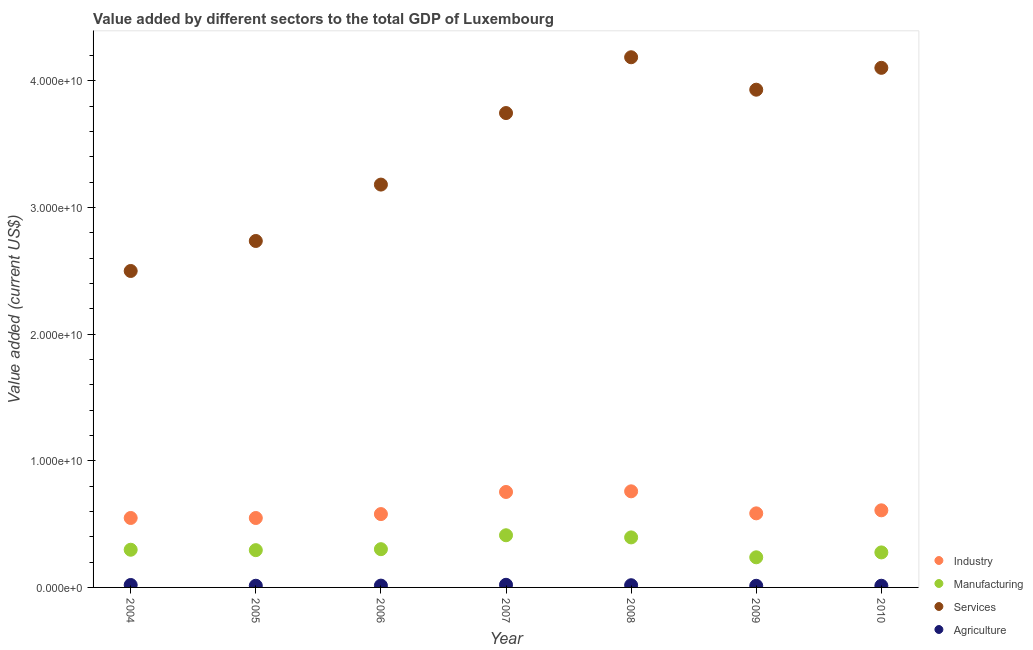How many different coloured dotlines are there?
Provide a succinct answer. 4. What is the value added by agricultural sector in 2005?
Provide a succinct answer. 1.33e+08. Across all years, what is the maximum value added by manufacturing sector?
Provide a short and direct response. 4.12e+09. Across all years, what is the minimum value added by services sector?
Your answer should be very brief. 2.50e+1. In which year was the value added by services sector minimum?
Your answer should be very brief. 2004. What is the total value added by industrial sector in the graph?
Keep it short and to the point. 4.38e+1. What is the difference between the value added by services sector in 2005 and that in 2008?
Offer a very short reply. -1.45e+1. What is the difference between the value added by agricultural sector in 2004 and the value added by services sector in 2005?
Provide a short and direct response. -2.72e+1. What is the average value added by industrial sector per year?
Offer a terse response. 6.26e+09. In the year 2006, what is the difference between the value added by agricultural sector and value added by services sector?
Your answer should be compact. -3.17e+1. In how many years, is the value added by agricultural sector greater than 2000000000 US$?
Your response must be concise. 0. What is the ratio of the value added by services sector in 2006 to that in 2010?
Ensure brevity in your answer.  0.78. Is the difference between the value added by services sector in 2005 and 2006 greater than the difference between the value added by industrial sector in 2005 and 2006?
Offer a very short reply. No. What is the difference between the highest and the second highest value added by agricultural sector?
Your answer should be compact. 1.63e+07. What is the difference between the highest and the lowest value added by manufacturing sector?
Keep it short and to the point. 1.74e+09. Is it the case that in every year, the sum of the value added by agricultural sector and value added by industrial sector is greater than the sum of value added by services sector and value added by manufacturing sector?
Your answer should be compact. No. Is it the case that in every year, the sum of the value added by industrial sector and value added by manufacturing sector is greater than the value added by services sector?
Offer a very short reply. No. Does the value added by agricultural sector monotonically increase over the years?
Keep it short and to the point. No. Is the value added by industrial sector strictly greater than the value added by manufacturing sector over the years?
Keep it short and to the point. Yes. Is the value added by manufacturing sector strictly less than the value added by industrial sector over the years?
Offer a very short reply. Yes. Are the values on the major ticks of Y-axis written in scientific E-notation?
Provide a short and direct response. Yes. Does the graph contain any zero values?
Offer a terse response. No. How are the legend labels stacked?
Keep it short and to the point. Vertical. What is the title of the graph?
Offer a terse response. Value added by different sectors to the total GDP of Luxembourg. What is the label or title of the X-axis?
Offer a terse response. Year. What is the label or title of the Y-axis?
Your answer should be compact. Value added (current US$). What is the Value added (current US$) in Industry in 2004?
Provide a short and direct response. 5.49e+09. What is the Value added (current US$) of Manufacturing in 2004?
Provide a succinct answer. 2.98e+09. What is the Value added (current US$) in Services in 2004?
Your answer should be very brief. 2.50e+1. What is the Value added (current US$) of Agriculture in 2004?
Your answer should be compact. 1.92e+08. What is the Value added (current US$) in Industry in 2005?
Give a very brief answer. 5.48e+09. What is the Value added (current US$) in Manufacturing in 2005?
Provide a short and direct response. 2.94e+09. What is the Value added (current US$) in Services in 2005?
Provide a succinct answer. 2.74e+1. What is the Value added (current US$) of Agriculture in 2005?
Your answer should be compact. 1.33e+08. What is the Value added (current US$) in Industry in 2006?
Give a very brief answer. 5.79e+09. What is the Value added (current US$) of Manufacturing in 2006?
Ensure brevity in your answer.  3.02e+09. What is the Value added (current US$) of Services in 2006?
Make the answer very short. 3.18e+1. What is the Value added (current US$) in Agriculture in 2006?
Your answer should be compact. 1.43e+08. What is the Value added (current US$) of Industry in 2007?
Your response must be concise. 7.54e+09. What is the Value added (current US$) of Manufacturing in 2007?
Offer a terse response. 4.12e+09. What is the Value added (current US$) of Services in 2007?
Your answer should be very brief. 3.75e+1. What is the Value added (current US$) in Agriculture in 2007?
Give a very brief answer. 2.08e+08. What is the Value added (current US$) in Industry in 2008?
Your answer should be compact. 7.59e+09. What is the Value added (current US$) in Manufacturing in 2008?
Your response must be concise. 3.95e+09. What is the Value added (current US$) in Services in 2008?
Your answer should be very brief. 4.19e+1. What is the Value added (current US$) of Agriculture in 2008?
Your response must be concise. 1.74e+08. What is the Value added (current US$) in Industry in 2009?
Make the answer very short. 5.85e+09. What is the Value added (current US$) of Manufacturing in 2009?
Ensure brevity in your answer.  2.38e+09. What is the Value added (current US$) in Services in 2009?
Make the answer very short. 3.93e+1. What is the Value added (current US$) in Agriculture in 2009?
Ensure brevity in your answer.  1.29e+08. What is the Value added (current US$) of Industry in 2010?
Offer a terse response. 6.09e+09. What is the Value added (current US$) in Manufacturing in 2010?
Keep it short and to the point. 2.77e+09. What is the Value added (current US$) in Services in 2010?
Give a very brief answer. 4.10e+1. What is the Value added (current US$) in Agriculture in 2010?
Give a very brief answer. 1.32e+08. Across all years, what is the maximum Value added (current US$) in Industry?
Ensure brevity in your answer.  7.59e+09. Across all years, what is the maximum Value added (current US$) of Manufacturing?
Your answer should be compact. 4.12e+09. Across all years, what is the maximum Value added (current US$) in Services?
Make the answer very short. 4.19e+1. Across all years, what is the maximum Value added (current US$) in Agriculture?
Offer a very short reply. 2.08e+08. Across all years, what is the minimum Value added (current US$) in Industry?
Give a very brief answer. 5.48e+09. Across all years, what is the minimum Value added (current US$) in Manufacturing?
Give a very brief answer. 2.38e+09. Across all years, what is the minimum Value added (current US$) in Services?
Your response must be concise. 2.50e+1. Across all years, what is the minimum Value added (current US$) in Agriculture?
Provide a succinct answer. 1.29e+08. What is the total Value added (current US$) of Industry in the graph?
Your answer should be very brief. 4.38e+1. What is the total Value added (current US$) of Manufacturing in the graph?
Your answer should be very brief. 2.22e+1. What is the total Value added (current US$) in Services in the graph?
Provide a succinct answer. 2.44e+11. What is the total Value added (current US$) in Agriculture in the graph?
Your answer should be compact. 1.11e+09. What is the difference between the Value added (current US$) of Industry in 2004 and that in 2005?
Your answer should be very brief. 2.57e+06. What is the difference between the Value added (current US$) of Manufacturing in 2004 and that in 2005?
Offer a terse response. 3.27e+07. What is the difference between the Value added (current US$) in Services in 2004 and that in 2005?
Offer a terse response. -2.37e+09. What is the difference between the Value added (current US$) of Agriculture in 2004 and that in 2005?
Offer a very short reply. 5.94e+07. What is the difference between the Value added (current US$) in Industry in 2004 and that in 2006?
Provide a succinct answer. -3.08e+08. What is the difference between the Value added (current US$) in Manufacturing in 2004 and that in 2006?
Your answer should be very brief. -4.37e+07. What is the difference between the Value added (current US$) in Services in 2004 and that in 2006?
Your answer should be compact. -6.82e+09. What is the difference between the Value added (current US$) of Agriculture in 2004 and that in 2006?
Offer a terse response. 4.88e+07. What is the difference between the Value added (current US$) in Industry in 2004 and that in 2007?
Your response must be concise. -2.05e+09. What is the difference between the Value added (current US$) in Manufacturing in 2004 and that in 2007?
Offer a very short reply. -1.14e+09. What is the difference between the Value added (current US$) of Services in 2004 and that in 2007?
Ensure brevity in your answer.  -1.25e+1. What is the difference between the Value added (current US$) of Agriculture in 2004 and that in 2007?
Keep it short and to the point. -1.63e+07. What is the difference between the Value added (current US$) of Industry in 2004 and that in 2008?
Offer a very short reply. -2.11e+09. What is the difference between the Value added (current US$) of Manufacturing in 2004 and that in 2008?
Your response must be concise. -9.74e+08. What is the difference between the Value added (current US$) of Services in 2004 and that in 2008?
Provide a short and direct response. -1.69e+1. What is the difference between the Value added (current US$) in Agriculture in 2004 and that in 2008?
Ensure brevity in your answer.  1.80e+07. What is the difference between the Value added (current US$) of Industry in 2004 and that in 2009?
Provide a short and direct response. -3.65e+08. What is the difference between the Value added (current US$) in Manufacturing in 2004 and that in 2009?
Offer a very short reply. 5.97e+08. What is the difference between the Value added (current US$) in Services in 2004 and that in 2009?
Your answer should be very brief. -1.43e+1. What is the difference between the Value added (current US$) in Agriculture in 2004 and that in 2009?
Make the answer very short. 6.30e+07. What is the difference between the Value added (current US$) in Industry in 2004 and that in 2010?
Your answer should be very brief. -6.05e+08. What is the difference between the Value added (current US$) of Manufacturing in 2004 and that in 2010?
Give a very brief answer. 2.12e+08. What is the difference between the Value added (current US$) of Services in 2004 and that in 2010?
Provide a short and direct response. -1.60e+1. What is the difference between the Value added (current US$) of Agriculture in 2004 and that in 2010?
Give a very brief answer. 5.98e+07. What is the difference between the Value added (current US$) of Industry in 2005 and that in 2006?
Offer a very short reply. -3.10e+08. What is the difference between the Value added (current US$) in Manufacturing in 2005 and that in 2006?
Offer a terse response. -7.64e+07. What is the difference between the Value added (current US$) of Services in 2005 and that in 2006?
Provide a succinct answer. -4.45e+09. What is the difference between the Value added (current US$) in Agriculture in 2005 and that in 2006?
Offer a very short reply. -1.06e+07. What is the difference between the Value added (current US$) of Industry in 2005 and that in 2007?
Your answer should be very brief. -2.06e+09. What is the difference between the Value added (current US$) in Manufacturing in 2005 and that in 2007?
Offer a terse response. -1.18e+09. What is the difference between the Value added (current US$) of Services in 2005 and that in 2007?
Make the answer very short. -1.01e+1. What is the difference between the Value added (current US$) in Agriculture in 2005 and that in 2007?
Make the answer very short. -7.56e+07. What is the difference between the Value added (current US$) in Industry in 2005 and that in 2008?
Your answer should be very brief. -2.11e+09. What is the difference between the Value added (current US$) of Manufacturing in 2005 and that in 2008?
Provide a short and direct response. -1.01e+09. What is the difference between the Value added (current US$) in Services in 2005 and that in 2008?
Make the answer very short. -1.45e+1. What is the difference between the Value added (current US$) of Agriculture in 2005 and that in 2008?
Your response must be concise. -4.13e+07. What is the difference between the Value added (current US$) of Industry in 2005 and that in 2009?
Give a very brief answer. -3.68e+08. What is the difference between the Value added (current US$) in Manufacturing in 2005 and that in 2009?
Give a very brief answer. 5.65e+08. What is the difference between the Value added (current US$) in Services in 2005 and that in 2009?
Offer a very short reply. -1.19e+1. What is the difference between the Value added (current US$) of Agriculture in 2005 and that in 2009?
Provide a short and direct response. 3.62e+06. What is the difference between the Value added (current US$) of Industry in 2005 and that in 2010?
Offer a terse response. -6.07e+08. What is the difference between the Value added (current US$) of Manufacturing in 2005 and that in 2010?
Your response must be concise. 1.79e+08. What is the difference between the Value added (current US$) of Services in 2005 and that in 2010?
Make the answer very short. -1.37e+1. What is the difference between the Value added (current US$) in Agriculture in 2005 and that in 2010?
Your response must be concise. 3.69e+05. What is the difference between the Value added (current US$) in Industry in 2006 and that in 2007?
Your response must be concise. -1.75e+09. What is the difference between the Value added (current US$) in Manufacturing in 2006 and that in 2007?
Ensure brevity in your answer.  -1.10e+09. What is the difference between the Value added (current US$) of Services in 2006 and that in 2007?
Make the answer very short. -5.65e+09. What is the difference between the Value added (current US$) of Agriculture in 2006 and that in 2007?
Offer a very short reply. -6.51e+07. What is the difference between the Value added (current US$) in Industry in 2006 and that in 2008?
Give a very brief answer. -1.80e+09. What is the difference between the Value added (current US$) in Manufacturing in 2006 and that in 2008?
Provide a succinct answer. -9.30e+08. What is the difference between the Value added (current US$) of Services in 2006 and that in 2008?
Give a very brief answer. -1.01e+1. What is the difference between the Value added (current US$) in Agriculture in 2006 and that in 2008?
Your response must be concise. -3.08e+07. What is the difference between the Value added (current US$) in Industry in 2006 and that in 2009?
Keep it short and to the point. -5.74e+07. What is the difference between the Value added (current US$) of Manufacturing in 2006 and that in 2009?
Provide a short and direct response. 6.41e+08. What is the difference between the Value added (current US$) of Services in 2006 and that in 2009?
Make the answer very short. -7.49e+09. What is the difference between the Value added (current US$) in Agriculture in 2006 and that in 2009?
Keep it short and to the point. 1.42e+07. What is the difference between the Value added (current US$) in Industry in 2006 and that in 2010?
Your answer should be compact. -2.97e+08. What is the difference between the Value added (current US$) in Manufacturing in 2006 and that in 2010?
Make the answer very short. 2.55e+08. What is the difference between the Value added (current US$) of Services in 2006 and that in 2010?
Your answer should be compact. -9.22e+09. What is the difference between the Value added (current US$) in Agriculture in 2006 and that in 2010?
Give a very brief answer. 1.09e+07. What is the difference between the Value added (current US$) in Industry in 2007 and that in 2008?
Provide a succinct answer. -5.10e+07. What is the difference between the Value added (current US$) of Manufacturing in 2007 and that in 2008?
Give a very brief answer. 1.70e+08. What is the difference between the Value added (current US$) of Services in 2007 and that in 2008?
Make the answer very short. -4.41e+09. What is the difference between the Value added (current US$) of Agriculture in 2007 and that in 2008?
Your answer should be compact. 3.43e+07. What is the difference between the Value added (current US$) of Industry in 2007 and that in 2009?
Offer a very short reply. 1.69e+09. What is the difference between the Value added (current US$) of Manufacturing in 2007 and that in 2009?
Give a very brief answer. 1.74e+09. What is the difference between the Value added (current US$) of Services in 2007 and that in 2009?
Make the answer very short. -1.84e+09. What is the difference between the Value added (current US$) in Agriculture in 2007 and that in 2009?
Provide a succinct answer. 7.93e+07. What is the difference between the Value added (current US$) of Industry in 2007 and that in 2010?
Your answer should be compact. 1.45e+09. What is the difference between the Value added (current US$) of Manufacturing in 2007 and that in 2010?
Your response must be concise. 1.36e+09. What is the difference between the Value added (current US$) of Services in 2007 and that in 2010?
Offer a very short reply. -3.57e+09. What is the difference between the Value added (current US$) in Agriculture in 2007 and that in 2010?
Provide a succinct answer. 7.60e+07. What is the difference between the Value added (current US$) of Industry in 2008 and that in 2009?
Ensure brevity in your answer.  1.74e+09. What is the difference between the Value added (current US$) in Manufacturing in 2008 and that in 2009?
Keep it short and to the point. 1.57e+09. What is the difference between the Value added (current US$) in Services in 2008 and that in 2009?
Ensure brevity in your answer.  2.56e+09. What is the difference between the Value added (current US$) in Agriculture in 2008 and that in 2009?
Provide a succinct answer. 4.50e+07. What is the difference between the Value added (current US$) of Industry in 2008 and that in 2010?
Your answer should be very brief. 1.50e+09. What is the difference between the Value added (current US$) in Manufacturing in 2008 and that in 2010?
Offer a very short reply. 1.19e+09. What is the difference between the Value added (current US$) in Services in 2008 and that in 2010?
Make the answer very short. 8.35e+08. What is the difference between the Value added (current US$) in Agriculture in 2008 and that in 2010?
Provide a succinct answer. 4.17e+07. What is the difference between the Value added (current US$) in Industry in 2009 and that in 2010?
Give a very brief answer. -2.40e+08. What is the difference between the Value added (current US$) of Manufacturing in 2009 and that in 2010?
Keep it short and to the point. -3.86e+08. What is the difference between the Value added (current US$) of Services in 2009 and that in 2010?
Provide a short and direct response. -1.73e+09. What is the difference between the Value added (current US$) in Agriculture in 2009 and that in 2010?
Provide a short and direct response. -3.25e+06. What is the difference between the Value added (current US$) in Industry in 2004 and the Value added (current US$) in Manufacturing in 2005?
Give a very brief answer. 2.54e+09. What is the difference between the Value added (current US$) of Industry in 2004 and the Value added (current US$) of Services in 2005?
Your answer should be compact. -2.19e+1. What is the difference between the Value added (current US$) in Industry in 2004 and the Value added (current US$) in Agriculture in 2005?
Make the answer very short. 5.35e+09. What is the difference between the Value added (current US$) of Manufacturing in 2004 and the Value added (current US$) of Services in 2005?
Keep it short and to the point. -2.44e+1. What is the difference between the Value added (current US$) in Manufacturing in 2004 and the Value added (current US$) in Agriculture in 2005?
Your response must be concise. 2.84e+09. What is the difference between the Value added (current US$) in Services in 2004 and the Value added (current US$) in Agriculture in 2005?
Your answer should be compact. 2.49e+1. What is the difference between the Value added (current US$) of Industry in 2004 and the Value added (current US$) of Manufacturing in 2006?
Make the answer very short. 2.46e+09. What is the difference between the Value added (current US$) of Industry in 2004 and the Value added (current US$) of Services in 2006?
Offer a very short reply. -2.63e+1. What is the difference between the Value added (current US$) of Industry in 2004 and the Value added (current US$) of Agriculture in 2006?
Ensure brevity in your answer.  5.34e+09. What is the difference between the Value added (current US$) of Manufacturing in 2004 and the Value added (current US$) of Services in 2006?
Provide a succinct answer. -2.88e+1. What is the difference between the Value added (current US$) of Manufacturing in 2004 and the Value added (current US$) of Agriculture in 2006?
Offer a terse response. 2.83e+09. What is the difference between the Value added (current US$) of Services in 2004 and the Value added (current US$) of Agriculture in 2006?
Provide a succinct answer. 2.49e+1. What is the difference between the Value added (current US$) of Industry in 2004 and the Value added (current US$) of Manufacturing in 2007?
Give a very brief answer. 1.36e+09. What is the difference between the Value added (current US$) in Industry in 2004 and the Value added (current US$) in Services in 2007?
Give a very brief answer. -3.20e+1. What is the difference between the Value added (current US$) in Industry in 2004 and the Value added (current US$) in Agriculture in 2007?
Provide a succinct answer. 5.28e+09. What is the difference between the Value added (current US$) in Manufacturing in 2004 and the Value added (current US$) in Services in 2007?
Your answer should be compact. -3.45e+1. What is the difference between the Value added (current US$) of Manufacturing in 2004 and the Value added (current US$) of Agriculture in 2007?
Your response must be concise. 2.77e+09. What is the difference between the Value added (current US$) in Services in 2004 and the Value added (current US$) in Agriculture in 2007?
Give a very brief answer. 2.48e+1. What is the difference between the Value added (current US$) of Industry in 2004 and the Value added (current US$) of Manufacturing in 2008?
Your response must be concise. 1.53e+09. What is the difference between the Value added (current US$) of Industry in 2004 and the Value added (current US$) of Services in 2008?
Provide a short and direct response. -3.64e+1. What is the difference between the Value added (current US$) in Industry in 2004 and the Value added (current US$) in Agriculture in 2008?
Give a very brief answer. 5.31e+09. What is the difference between the Value added (current US$) of Manufacturing in 2004 and the Value added (current US$) of Services in 2008?
Ensure brevity in your answer.  -3.89e+1. What is the difference between the Value added (current US$) of Manufacturing in 2004 and the Value added (current US$) of Agriculture in 2008?
Give a very brief answer. 2.80e+09. What is the difference between the Value added (current US$) of Services in 2004 and the Value added (current US$) of Agriculture in 2008?
Provide a succinct answer. 2.48e+1. What is the difference between the Value added (current US$) in Industry in 2004 and the Value added (current US$) in Manufacturing in 2009?
Keep it short and to the point. 3.11e+09. What is the difference between the Value added (current US$) of Industry in 2004 and the Value added (current US$) of Services in 2009?
Ensure brevity in your answer.  -3.38e+1. What is the difference between the Value added (current US$) of Industry in 2004 and the Value added (current US$) of Agriculture in 2009?
Your answer should be compact. 5.36e+09. What is the difference between the Value added (current US$) in Manufacturing in 2004 and the Value added (current US$) in Services in 2009?
Provide a succinct answer. -3.63e+1. What is the difference between the Value added (current US$) of Manufacturing in 2004 and the Value added (current US$) of Agriculture in 2009?
Offer a terse response. 2.85e+09. What is the difference between the Value added (current US$) of Services in 2004 and the Value added (current US$) of Agriculture in 2009?
Make the answer very short. 2.49e+1. What is the difference between the Value added (current US$) of Industry in 2004 and the Value added (current US$) of Manufacturing in 2010?
Your response must be concise. 2.72e+09. What is the difference between the Value added (current US$) of Industry in 2004 and the Value added (current US$) of Services in 2010?
Provide a succinct answer. -3.56e+1. What is the difference between the Value added (current US$) of Industry in 2004 and the Value added (current US$) of Agriculture in 2010?
Make the answer very short. 5.35e+09. What is the difference between the Value added (current US$) in Manufacturing in 2004 and the Value added (current US$) in Services in 2010?
Provide a succinct answer. -3.81e+1. What is the difference between the Value added (current US$) of Manufacturing in 2004 and the Value added (current US$) of Agriculture in 2010?
Your response must be concise. 2.84e+09. What is the difference between the Value added (current US$) of Services in 2004 and the Value added (current US$) of Agriculture in 2010?
Give a very brief answer. 2.49e+1. What is the difference between the Value added (current US$) of Industry in 2005 and the Value added (current US$) of Manufacturing in 2006?
Give a very brief answer. 2.46e+09. What is the difference between the Value added (current US$) in Industry in 2005 and the Value added (current US$) in Services in 2006?
Your answer should be compact. -2.63e+1. What is the difference between the Value added (current US$) in Industry in 2005 and the Value added (current US$) in Agriculture in 2006?
Your answer should be compact. 5.34e+09. What is the difference between the Value added (current US$) of Manufacturing in 2005 and the Value added (current US$) of Services in 2006?
Give a very brief answer. -2.89e+1. What is the difference between the Value added (current US$) of Manufacturing in 2005 and the Value added (current US$) of Agriculture in 2006?
Offer a very short reply. 2.80e+09. What is the difference between the Value added (current US$) in Services in 2005 and the Value added (current US$) in Agriculture in 2006?
Provide a short and direct response. 2.72e+1. What is the difference between the Value added (current US$) in Industry in 2005 and the Value added (current US$) in Manufacturing in 2007?
Ensure brevity in your answer.  1.36e+09. What is the difference between the Value added (current US$) of Industry in 2005 and the Value added (current US$) of Services in 2007?
Ensure brevity in your answer.  -3.20e+1. What is the difference between the Value added (current US$) in Industry in 2005 and the Value added (current US$) in Agriculture in 2007?
Give a very brief answer. 5.27e+09. What is the difference between the Value added (current US$) in Manufacturing in 2005 and the Value added (current US$) in Services in 2007?
Your answer should be very brief. -3.45e+1. What is the difference between the Value added (current US$) of Manufacturing in 2005 and the Value added (current US$) of Agriculture in 2007?
Offer a terse response. 2.74e+09. What is the difference between the Value added (current US$) of Services in 2005 and the Value added (current US$) of Agriculture in 2007?
Your answer should be very brief. 2.72e+1. What is the difference between the Value added (current US$) in Industry in 2005 and the Value added (current US$) in Manufacturing in 2008?
Your answer should be very brief. 1.53e+09. What is the difference between the Value added (current US$) in Industry in 2005 and the Value added (current US$) in Services in 2008?
Provide a succinct answer. -3.64e+1. What is the difference between the Value added (current US$) in Industry in 2005 and the Value added (current US$) in Agriculture in 2008?
Ensure brevity in your answer.  5.31e+09. What is the difference between the Value added (current US$) in Manufacturing in 2005 and the Value added (current US$) in Services in 2008?
Offer a very short reply. -3.89e+1. What is the difference between the Value added (current US$) of Manufacturing in 2005 and the Value added (current US$) of Agriculture in 2008?
Your answer should be compact. 2.77e+09. What is the difference between the Value added (current US$) in Services in 2005 and the Value added (current US$) in Agriculture in 2008?
Your response must be concise. 2.72e+1. What is the difference between the Value added (current US$) in Industry in 2005 and the Value added (current US$) in Manufacturing in 2009?
Ensure brevity in your answer.  3.10e+09. What is the difference between the Value added (current US$) of Industry in 2005 and the Value added (current US$) of Services in 2009?
Make the answer very short. -3.38e+1. What is the difference between the Value added (current US$) in Industry in 2005 and the Value added (current US$) in Agriculture in 2009?
Offer a very short reply. 5.35e+09. What is the difference between the Value added (current US$) in Manufacturing in 2005 and the Value added (current US$) in Services in 2009?
Keep it short and to the point. -3.64e+1. What is the difference between the Value added (current US$) in Manufacturing in 2005 and the Value added (current US$) in Agriculture in 2009?
Make the answer very short. 2.82e+09. What is the difference between the Value added (current US$) of Services in 2005 and the Value added (current US$) of Agriculture in 2009?
Your answer should be compact. 2.72e+1. What is the difference between the Value added (current US$) of Industry in 2005 and the Value added (current US$) of Manufacturing in 2010?
Your response must be concise. 2.72e+09. What is the difference between the Value added (current US$) of Industry in 2005 and the Value added (current US$) of Services in 2010?
Keep it short and to the point. -3.56e+1. What is the difference between the Value added (current US$) of Industry in 2005 and the Value added (current US$) of Agriculture in 2010?
Offer a very short reply. 5.35e+09. What is the difference between the Value added (current US$) in Manufacturing in 2005 and the Value added (current US$) in Services in 2010?
Your answer should be compact. -3.81e+1. What is the difference between the Value added (current US$) of Manufacturing in 2005 and the Value added (current US$) of Agriculture in 2010?
Ensure brevity in your answer.  2.81e+09. What is the difference between the Value added (current US$) in Services in 2005 and the Value added (current US$) in Agriculture in 2010?
Make the answer very short. 2.72e+1. What is the difference between the Value added (current US$) in Industry in 2006 and the Value added (current US$) in Manufacturing in 2007?
Offer a terse response. 1.67e+09. What is the difference between the Value added (current US$) in Industry in 2006 and the Value added (current US$) in Services in 2007?
Make the answer very short. -3.17e+1. What is the difference between the Value added (current US$) in Industry in 2006 and the Value added (current US$) in Agriculture in 2007?
Ensure brevity in your answer.  5.58e+09. What is the difference between the Value added (current US$) in Manufacturing in 2006 and the Value added (current US$) in Services in 2007?
Your answer should be very brief. -3.44e+1. What is the difference between the Value added (current US$) of Manufacturing in 2006 and the Value added (current US$) of Agriculture in 2007?
Your answer should be compact. 2.81e+09. What is the difference between the Value added (current US$) of Services in 2006 and the Value added (current US$) of Agriculture in 2007?
Your answer should be very brief. 3.16e+1. What is the difference between the Value added (current US$) in Industry in 2006 and the Value added (current US$) in Manufacturing in 2008?
Your answer should be compact. 1.84e+09. What is the difference between the Value added (current US$) of Industry in 2006 and the Value added (current US$) of Services in 2008?
Your response must be concise. -3.61e+1. What is the difference between the Value added (current US$) of Industry in 2006 and the Value added (current US$) of Agriculture in 2008?
Offer a terse response. 5.62e+09. What is the difference between the Value added (current US$) of Manufacturing in 2006 and the Value added (current US$) of Services in 2008?
Your answer should be very brief. -3.89e+1. What is the difference between the Value added (current US$) in Manufacturing in 2006 and the Value added (current US$) in Agriculture in 2008?
Ensure brevity in your answer.  2.85e+09. What is the difference between the Value added (current US$) of Services in 2006 and the Value added (current US$) of Agriculture in 2008?
Keep it short and to the point. 3.16e+1. What is the difference between the Value added (current US$) in Industry in 2006 and the Value added (current US$) in Manufacturing in 2009?
Offer a terse response. 3.41e+09. What is the difference between the Value added (current US$) of Industry in 2006 and the Value added (current US$) of Services in 2009?
Give a very brief answer. -3.35e+1. What is the difference between the Value added (current US$) in Industry in 2006 and the Value added (current US$) in Agriculture in 2009?
Your response must be concise. 5.66e+09. What is the difference between the Value added (current US$) of Manufacturing in 2006 and the Value added (current US$) of Services in 2009?
Provide a succinct answer. -3.63e+1. What is the difference between the Value added (current US$) in Manufacturing in 2006 and the Value added (current US$) in Agriculture in 2009?
Make the answer very short. 2.89e+09. What is the difference between the Value added (current US$) in Services in 2006 and the Value added (current US$) in Agriculture in 2009?
Ensure brevity in your answer.  3.17e+1. What is the difference between the Value added (current US$) in Industry in 2006 and the Value added (current US$) in Manufacturing in 2010?
Give a very brief answer. 3.03e+09. What is the difference between the Value added (current US$) in Industry in 2006 and the Value added (current US$) in Services in 2010?
Provide a succinct answer. -3.52e+1. What is the difference between the Value added (current US$) in Industry in 2006 and the Value added (current US$) in Agriculture in 2010?
Offer a very short reply. 5.66e+09. What is the difference between the Value added (current US$) of Manufacturing in 2006 and the Value added (current US$) of Services in 2010?
Offer a terse response. -3.80e+1. What is the difference between the Value added (current US$) in Manufacturing in 2006 and the Value added (current US$) in Agriculture in 2010?
Your answer should be compact. 2.89e+09. What is the difference between the Value added (current US$) in Services in 2006 and the Value added (current US$) in Agriculture in 2010?
Offer a very short reply. 3.17e+1. What is the difference between the Value added (current US$) of Industry in 2007 and the Value added (current US$) of Manufacturing in 2008?
Make the answer very short. 3.59e+09. What is the difference between the Value added (current US$) in Industry in 2007 and the Value added (current US$) in Services in 2008?
Ensure brevity in your answer.  -3.43e+1. What is the difference between the Value added (current US$) in Industry in 2007 and the Value added (current US$) in Agriculture in 2008?
Make the answer very short. 7.37e+09. What is the difference between the Value added (current US$) in Manufacturing in 2007 and the Value added (current US$) in Services in 2008?
Your response must be concise. -3.78e+1. What is the difference between the Value added (current US$) in Manufacturing in 2007 and the Value added (current US$) in Agriculture in 2008?
Your answer should be very brief. 3.95e+09. What is the difference between the Value added (current US$) of Services in 2007 and the Value added (current US$) of Agriculture in 2008?
Provide a succinct answer. 3.73e+1. What is the difference between the Value added (current US$) of Industry in 2007 and the Value added (current US$) of Manufacturing in 2009?
Your answer should be very brief. 5.16e+09. What is the difference between the Value added (current US$) of Industry in 2007 and the Value added (current US$) of Services in 2009?
Ensure brevity in your answer.  -3.18e+1. What is the difference between the Value added (current US$) of Industry in 2007 and the Value added (current US$) of Agriculture in 2009?
Your answer should be compact. 7.41e+09. What is the difference between the Value added (current US$) of Manufacturing in 2007 and the Value added (current US$) of Services in 2009?
Your answer should be compact. -3.52e+1. What is the difference between the Value added (current US$) of Manufacturing in 2007 and the Value added (current US$) of Agriculture in 2009?
Provide a short and direct response. 3.99e+09. What is the difference between the Value added (current US$) of Services in 2007 and the Value added (current US$) of Agriculture in 2009?
Your answer should be compact. 3.73e+1. What is the difference between the Value added (current US$) in Industry in 2007 and the Value added (current US$) in Manufacturing in 2010?
Provide a short and direct response. 4.77e+09. What is the difference between the Value added (current US$) in Industry in 2007 and the Value added (current US$) in Services in 2010?
Your answer should be very brief. -3.35e+1. What is the difference between the Value added (current US$) in Industry in 2007 and the Value added (current US$) in Agriculture in 2010?
Offer a very short reply. 7.41e+09. What is the difference between the Value added (current US$) of Manufacturing in 2007 and the Value added (current US$) of Services in 2010?
Your answer should be compact. -3.69e+1. What is the difference between the Value added (current US$) of Manufacturing in 2007 and the Value added (current US$) of Agriculture in 2010?
Offer a terse response. 3.99e+09. What is the difference between the Value added (current US$) of Services in 2007 and the Value added (current US$) of Agriculture in 2010?
Keep it short and to the point. 3.73e+1. What is the difference between the Value added (current US$) in Industry in 2008 and the Value added (current US$) in Manufacturing in 2009?
Your answer should be very brief. 5.21e+09. What is the difference between the Value added (current US$) of Industry in 2008 and the Value added (current US$) of Services in 2009?
Keep it short and to the point. -3.17e+1. What is the difference between the Value added (current US$) of Industry in 2008 and the Value added (current US$) of Agriculture in 2009?
Provide a succinct answer. 7.46e+09. What is the difference between the Value added (current US$) in Manufacturing in 2008 and the Value added (current US$) in Services in 2009?
Your answer should be very brief. -3.54e+1. What is the difference between the Value added (current US$) of Manufacturing in 2008 and the Value added (current US$) of Agriculture in 2009?
Make the answer very short. 3.82e+09. What is the difference between the Value added (current US$) in Services in 2008 and the Value added (current US$) in Agriculture in 2009?
Your response must be concise. 4.17e+1. What is the difference between the Value added (current US$) of Industry in 2008 and the Value added (current US$) of Manufacturing in 2010?
Your answer should be compact. 4.83e+09. What is the difference between the Value added (current US$) of Industry in 2008 and the Value added (current US$) of Services in 2010?
Provide a short and direct response. -3.34e+1. What is the difference between the Value added (current US$) in Industry in 2008 and the Value added (current US$) in Agriculture in 2010?
Your answer should be compact. 7.46e+09. What is the difference between the Value added (current US$) of Manufacturing in 2008 and the Value added (current US$) of Services in 2010?
Make the answer very short. -3.71e+1. What is the difference between the Value added (current US$) of Manufacturing in 2008 and the Value added (current US$) of Agriculture in 2010?
Ensure brevity in your answer.  3.82e+09. What is the difference between the Value added (current US$) of Services in 2008 and the Value added (current US$) of Agriculture in 2010?
Give a very brief answer. 4.17e+1. What is the difference between the Value added (current US$) in Industry in 2009 and the Value added (current US$) in Manufacturing in 2010?
Provide a short and direct response. 3.09e+09. What is the difference between the Value added (current US$) of Industry in 2009 and the Value added (current US$) of Services in 2010?
Your response must be concise. -3.52e+1. What is the difference between the Value added (current US$) of Industry in 2009 and the Value added (current US$) of Agriculture in 2010?
Your answer should be compact. 5.72e+09. What is the difference between the Value added (current US$) of Manufacturing in 2009 and the Value added (current US$) of Services in 2010?
Offer a terse response. -3.87e+1. What is the difference between the Value added (current US$) in Manufacturing in 2009 and the Value added (current US$) in Agriculture in 2010?
Your response must be concise. 2.25e+09. What is the difference between the Value added (current US$) of Services in 2009 and the Value added (current US$) of Agriculture in 2010?
Provide a short and direct response. 3.92e+1. What is the average Value added (current US$) of Industry per year?
Give a very brief answer. 6.26e+09. What is the average Value added (current US$) in Manufacturing per year?
Keep it short and to the point. 3.17e+09. What is the average Value added (current US$) in Services per year?
Give a very brief answer. 3.48e+1. What is the average Value added (current US$) in Agriculture per year?
Make the answer very short. 1.59e+08. In the year 2004, what is the difference between the Value added (current US$) of Industry and Value added (current US$) of Manufacturing?
Provide a short and direct response. 2.51e+09. In the year 2004, what is the difference between the Value added (current US$) in Industry and Value added (current US$) in Services?
Make the answer very short. -1.95e+1. In the year 2004, what is the difference between the Value added (current US$) of Industry and Value added (current US$) of Agriculture?
Your answer should be compact. 5.29e+09. In the year 2004, what is the difference between the Value added (current US$) of Manufacturing and Value added (current US$) of Services?
Give a very brief answer. -2.20e+1. In the year 2004, what is the difference between the Value added (current US$) of Manufacturing and Value added (current US$) of Agriculture?
Provide a succinct answer. 2.78e+09. In the year 2004, what is the difference between the Value added (current US$) of Services and Value added (current US$) of Agriculture?
Your answer should be very brief. 2.48e+1. In the year 2005, what is the difference between the Value added (current US$) in Industry and Value added (current US$) in Manufacturing?
Ensure brevity in your answer.  2.54e+09. In the year 2005, what is the difference between the Value added (current US$) of Industry and Value added (current US$) of Services?
Offer a terse response. -2.19e+1. In the year 2005, what is the difference between the Value added (current US$) of Industry and Value added (current US$) of Agriculture?
Provide a succinct answer. 5.35e+09. In the year 2005, what is the difference between the Value added (current US$) of Manufacturing and Value added (current US$) of Services?
Offer a terse response. -2.44e+1. In the year 2005, what is the difference between the Value added (current US$) of Manufacturing and Value added (current US$) of Agriculture?
Your response must be concise. 2.81e+09. In the year 2005, what is the difference between the Value added (current US$) in Services and Value added (current US$) in Agriculture?
Your answer should be very brief. 2.72e+1. In the year 2006, what is the difference between the Value added (current US$) of Industry and Value added (current US$) of Manufacturing?
Your answer should be compact. 2.77e+09. In the year 2006, what is the difference between the Value added (current US$) of Industry and Value added (current US$) of Services?
Keep it short and to the point. -2.60e+1. In the year 2006, what is the difference between the Value added (current US$) of Industry and Value added (current US$) of Agriculture?
Provide a short and direct response. 5.65e+09. In the year 2006, what is the difference between the Value added (current US$) in Manufacturing and Value added (current US$) in Services?
Ensure brevity in your answer.  -2.88e+1. In the year 2006, what is the difference between the Value added (current US$) of Manufacturing and Value added (current US$) of Agriculture?
Give a very brief answer. 2.88e+09. In the year 2006, what is the difference between the Value added (current US$) of Services and Value added (current US$) of Agriculture?
Your response must be concise. 3.17e+1. In the year 2007, what is the difference between the Value added (current US$) in Industry and Value added (current US$) in Manufacturing?
Your response must be concise. 3.42e+09. In the year 2007, what is the difference between the Value added (current US$) of Industry and Value added (current US$) of Services?
Make the answer very short. -2.99e+1. In the year 2007, what is the difference between the Value added (current US$) of Industry and Value added (current US$) of Agriculture?
Give a very brief answer. 7.33e+09. In the year 2007, what is the difference between the Value added (current US$) in Manufacturing and Value added (current US$) in Services?
Provide a succinct answer. -3.33e+1. In the year 2007, what is the difference between the Value added (current US$) of Manufacturing and Value added (current US$) of Agriculture?
Make the answer very short. 3.91e+09. In the year 2007, what is the difference between the Value added (current US$) in Services and Value added (current US$) in Agriculture?
Offer a terse response. 3.73e+1. In the year 2008, what is the difference between the Value added (current US$) in Industry and Value added (current US$) in Manufacturing?
Your response must be concise. 3.64e+09. In the year 2008, what is the difference between the Value added (current US$) in Industry and Value added (current US$) in Services?
Offer a very short reply. -3.43e+1. In the year 2008, what is the difference between the Value added (current US$) of Industry and Value added (current US$) of Agriculture?
Provide a succinct answer. 7.42e+09. In the year 2008, what is the difference between the Value added (current US$) in Manufacturing and Value added (current US$) in Services?
Your answer should be very brief. -3.79e+1. In the year 2008, what is the difference between the Value added (current US$) of Manufacturing and Value added (current US$) of Agriculture?
Give a very brief answer. 3.78e+09. In the year 2008, what is the difference between the Value added (current US$) in Services and Value added (current US$) in Agriculture?
Your answer should be very brief. 4.17e+1. In the year 2009, what is the difference between the Value added (current US$) of Industry and Value added (current US$) of Manufacturing?
Make the answer very short. 3.47e+09. In the year 2009, what is the difference between the Value added (current US$) in Industry and Value added (current US$) in Services?
Provide a short and direct response. -3.35e+1. In the year 2009, what is the difference between the Value added (current US$) in Industry and Value added (current US$) in Agriculture?
Offer a very short reply. 5.72e+09. In the year 2009, what is the difference between the Value added (current US$) in Manufacturing and Value added (current US$) in Services?
Offer a terse response. -3.69e+1. In the year 2009, what is the difference between the Value added (current US$) in Manufacturing and Value added (current US$) in Agriculture?
Ensure brevity in your answer.  2.25e+09. In the year 2009, what is the difference between the Value added (current US$) of Services and Value added (current US$) of Agriculture?
Provide a short and direct response. 3.92e+1. In the year 2010, what is the difference between the Value added (current US$) in Industry and Value added (current US$) in Manufacturing?
Give a very brief answer. 3.32e+09. In the year 2010, what is the difference between the Value added (current US$) in Industry and Value added (current US$) in Services?
Give a very brief answer. -3.49e+1. In the year 2010, what is the difference between the Value added (current US$) in Industry and Value added (current US$) in Agriculture?
Keep it short and to the point. 5.96e+09. In the year 2010, what is the difference between the Value added (current US$) in Manufacturing and Value added (current US$) in Services?
Ensure brevity in your answer.  -3.83e+1. In the year 2010, what is the difference between the Value added (current US$) in Manufacturing and Value added (current US$) in Agriculture?
Your answer should be very brief. 2.63e+09. In the year 2010, what is the difference between the Value added (current US$) of Services and Value added (current US$) of Agriculture?
Make the answer very short. 4.09e+1. What is the ratio of the Value added (current US$) in Industry in 2004 to that in 2005?
Make the answer very short. 1. What is the ratio of the Value added (current US$) in Manufacturing in 2004 to that in 2005?
Your response must be concise. 1.01. What is the ratio of the Value added (current US$) in Services in 2004 to that in 2005?
Ensure brevity in your answer.  0.91. What is the ratio of the Value added (current US$) in Agriculture in 2004 to that in 2005?
Keep it short and to the point. 1.45. What is the ratio of the Value added (current US$) in Industry in 2004 to that in 2006?
Your response must be concise. 0.95. What is the ratio of the Value added (current US$) in Manufacturing in 2004 to that in 2006?
Ensure brevity in your answer.  0.99. What is the ratio of the Value added (current US$) in Services in 2004 to that in 2006?
Ensure brevity in your answer.  0.79. What is the ratio of the Value added (current US$) in Agriculture in 2004 to that in 2006?
Make the answer very short. 1.34. What is the ratio of the Value added (current US$) in Industry in 2004 to that in 2007?
Give a very brief answer. 0.73. What is the ratio of the Value added (current US$) of Manufacturing in 2004 to that in 2007?
Offer a very short reply. 0.72. What is the ratio of the Value added (current US$) in Services in 2004 to that in 2007?
Make the answer very short. 0.67. What is the ratio of the Value added (current US$) in Agriculture in 2004 to that in 2007?
Your response must be concise. 0.92. What is the ratio of the Value added (current US$) in Industry in 2004 to that in 2008?
Your answer should be very brief. 0.72. What is the ratio of the Value added (current US$) in Manufacturing in 2004 to that in 2008?
Your response must be concise. 0.75. What is the ratio of the Value added (current US$) of Services in 2004 to that in 2008?
Ensure brevity in your answer.  0.6. What is the ratio of the Value added (current US$) of Agriculture in 2004 to that in 2008?
Make the answer very short. 1.1. What is the ratio of the Value added (current US$) in Industry in 2004 to that in 2009?
Make the answer very short. 0.94. What is the ratio of the Value added (current US$) of Manufacturing in 2004 to that in 2009?
Make the answer very short. 1.25. What is the ratio of the Value added (current US$) in Services in 2004 to that in 2009?
Offer a very short reply. 0.64. What is the ratio of the Value added (current US$) in Agriculture in 2004 to that in 2009?
Offer a very short reply. 1.49. What is the ratio of the Value added (current US$) of Industry in 2004 to that in 2010?
Provide a succinct answer. 0.9. What is the ratio of the Value added (current US$) in Manufacturing in 2004 to that in 2010?
Offer a very short reply. 1.08. What is the ratio of the Value added (current US$) of Services in 2004 to that in 2010?
Offer a terse response. 0.61. What is the ratio of the Value added (current US$) in Agriculture in 2004 to that in 2010?
Your answer should be compact. 1.45. What is the ratio of the Value added (current US$) of Industry in 2005 to that in 2006?
Offer a terse response. 0.95. What is the ratio of the Value added (current US$) in Manufacturing in 2005 to that in 2006?
Provide a succinct answer. 0.97. What is the ratio of the Value added (current US$) in Services in 2005 to that in 2006?
Your answer should be very brief. 0.86. What is the ratio of the Value added (current US$) in Agriculture in 2005 to that in 2006?
Your answer should be very brief. 0.93. What is the ratio of the Value added (current US$) of Industry in 2005 to that in 2007?
Provide a succinct answer. 0.73. What is the ratio of the Value added (current US$) of Manufacturing in 2005 to that in 2007?
Your answer should be very brief. 0.71. What is the ratio of the Value added (current US$) of Services in 2005 to that in 2007?
Give a very brief answer. 0.73. What is the ratio of the Value added (current US$) in Agriculture in 2005 to that in 2007?
Offer a very short reply. 0.64. What is the ratio of the Value added (current US$) of Industry in 2005 to that in 2008?
Keep it short and to the point. 0.72. What is the ratio of the Value added (current US$) in Manufacturing in 2005 to that in 2008?
Provide a succinct answer. 0.75. What is the ratio of the Value added (current US$) in Services in 2005 to that in 2008?
Your response must be concise. 0.65. What is the ratio of the Value added (current US$) of Agriculture in 2005 to that in 2008?
Your answer should be very brief. 0.76. What is the ratio of the Value added (current US$) of Industry in 2005 to that in 2009?
Ensure brevity in your answer.  0.94. What is the ratio of the Value added (current US$) in Manufacturing in 2005 to that in 2009?
Keep it short and to the point. 1.24. What is the ratio of the Value added (current US$) in Services in 2005 to that in 2009?
Ensure brevity in your answer.  0.7. What is the ratio of the Value added (current US$) in Agriculture in 2005 to that in 2009?
Your response must be concise. 1.03. What is the ratio of the Value added (current US$) in Industry in 2005 to that in 2010?
Offer a terse response. 0.9. What is the ratio of the Value added (current US$) in Manufacturing in 2005 to that in 2010?
Offer a terse response. 1.06. What is the ratio of the Value added (current US$) in Services in 2005 to that in 2010?
Provide a short and direct response. 0.67. What is the ratio of the Value added (current US$) of Industry in 2006 to that in 2007?
Provide a short and direct response. 0.77. What is the ratio of the Value added (current US$) in Manufacturing in 2006 to that in 2007?
Ensure brevity in your answer.  0.73. What is the ratio of the Value added (current US$) of Services in 2006 to that in 2007?
Provide a short and direct response. 0.85. What is the ratio of the Value added (current US$) in Agriculture in 2006 to that in 2007?
Offer a very short reply. 0.69. What is the ratio of the Value added (current US$) of Industry in 2006 to that in 2008?
Offer a very short reply. 0.76. What is the ratio of the Value added (current US$) of Manufacturing in 2006 to that in 2008?
Your answer should be compact. 0.76. What is the ratio of the Value added (current US$) of Services in 2006 to that in 2008?
Keep it short and to the point. 0.76. What is the ratio of the Value added (current US$) in Agriculture in 2006 to that in 2008?
Your answer should be compact. 0.82. What is the ratio of the Value added (current US$) in Industry in 2006 to that in 2009?
Keep it short and to the point. 0.99. What is the ratio of the Value added (current US$) of Manufacturing in 2006 to that in 2009?
Make the answer very short. 1.27. What is the ratio of the Value added (current US$) in Services in 2006 to that in 2009?
Provide a short and direct response. 0.81. What is the ratio of the Value added (current US$) of Agriculture in 2006 to that in 2009?
Provide a short and direct response. 1.11. What is the ratio of the Value added (current US$) of Industry in 2006 to that in 2010?
Provide a short and direct response. 0.95. What is the ratio of the Value added (current US$) of Manufacturing in 2006 to that in 2010?
Your answer should be compact. 1.09. What is the ratio of the Value added (current US$) in Services in 2006 to that in 2010?
Keep it short and to the point. 0.78. What is the ratio of the Value added (current US$) in Agriculture in 2006 to that in 2010?
Your response must be concise. 1.08. What is the ratio of the Value added (current US$) in Manufacturing in 2007 to that in 2008?
Your response must be concise. 1.04. What is the ratio of the Value added (current US$) of Services in 2007 to that in 2008?
Keep it short and to the point. 0.89. What is the ratio of the Value added (current US$) of Agriculture in 2007 to that in 2008?
Offer a very short reply. 1.2. What is the ratio of the Value added (current US$) in Industry in 2007 to that in 2009?
Provide a succinct answer. 1.29. What is the ratio of the Value added (current US$) of Manufacturing in 2007 to that in 2009?
Keep it short and to the point. 1.73. What is the ratio of the Value added (current US$) in Services in 2007 to that in 2009?
Your answer should be very brief. 0.95. What is the ratio of the Value added (current US$) in Agriculture in 2007 to that in 2009?
Keep it short and to the point. 1.61. What is the ratio of the Value added (current US$) of Industry in 2007 to that in 2010?
Your response must be concise. 1.24. What is the ratio of the Value added (current US$) in Manufacturing in 2007 to that in 2010?
Your answer should be compact. 1.49. What is the ratio of the Value added (current US$) of Agriculture in 2007 to that in 2010?
Your answer should be compact. 1.57. What is the ratio of the Value added (current US$) in Industry in 2008 to that in 2009?
Provide a short and direct response. 1.3. What is the ratio of the Value added (current US$) of Manufacturing in 2008 to that in 2009?
Ensure brevity in your answer.  1.66. What is the ratio of the Value added (current US$) of Services in 2008 to that in 2009?
Make the answer very short. 1.07. What is the ratio of the Value added (current US$) of Agriculture in 2008 to that in 2009?
Your response must be concise. 1.35. What is the ratio of the Value added (current US$) of Industry in 2008 to that in 2010?
Your response must be concise. 1.25. What is the ratio of the Value added (current US$) of Manufacturing in 2008 to that in 2010?
Give a very brief answer. 1.43. What is the ratio of the Value added (current US$) in Services in 2008 to that in 2010?
Provide a succinct answer. 1.02. What is the ratio of the Value added (current US$) in Agriculture in 2008 to that in 2010?
Make the answer very short. 1.31. What is the ratio of the Value added (current US$) in Industry in 2009 to that in 2010?
Offer a terse response. 0.96. What is the ratio of the Value added (current US$) of Manufacturing in 2009 to that in 2010?
Give a very brief answer. 0.86. What is the ratio of the Value added (current US$) in Services in 2009 to that in 2010?
Offer a terse response. 0.96. What is the ratio of the Value added (current US$) in Agriculture in 2009 to that in 2010?
Make the answer very short. 0.98. What is the difference between the highest and the second highest Value added (current US$) in Industry?
Offer a very short reply. 5.10e+07. What is the difference between the highest and the second highest Value added (current US$) of Manufacturing?
Make the answer very short. 1.70e+08. What is the difference between the highest and the second highest Value added (current US$) in Services?
Ensure brevity in your answer.  8.35e+08. What is the difference between the highest and the second highest Value added (current US$) in Agriculture?
Your response must be concise. 1.63e+07. What is the difference between the highest and the lowest Value added (current US$) in Industry?
Ensure brevity in your answer.  2.11e+09. What is the difference between the highest and the lowest Value added (current US$) of Manufacturing?
Your answer should be very brief. 1.74e+09. What is the difference between the highest and the lowest Value added (current US$) in Services?
Provide a succinct answer. 1.69e+1. What is the difference between the highest and the lowest Value added (current US$) in Agriculture?
Give a very brief answer. 7.93e+07. 